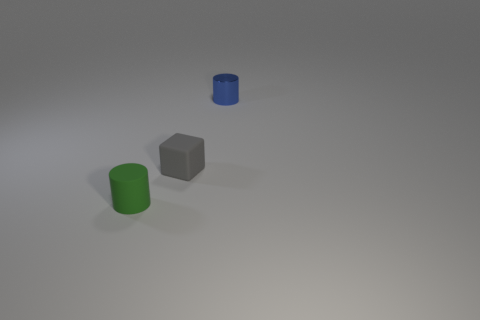What color is the small metallic cylinder?
Give a very brief answer. Blue. There is a cylinder that is left of the small blue object; does it have the same color as the shiny object?
Provide a succinct answer. No. What number of objects are either matte things that are behind the green matte object or large gray metallic blocks?
Offer a terse response. 1. What number of gray things are either tiny matte cylinders or small rubber objects?
Offer a terse response. 1. How many other objects are there of the same color as the matte block?
Keep it short and to the point. 0. Are there fewer matte cubes that are on the right side of the metallic thing than large gray things?
Your answer should be very brief. No. There is a cylinder that is to the right of the cylinder that is in front of the cylinder to the right of the gray rubber block; what color is it?
Your answer should be very brief. Blue. Is there any other thing that is made of the same material as the blue thing?
Provide a short and direct response. No. Is the number of small green cylinders that are in front of the small green cylinder less than the number of gray blocks that are in front of the metal thing?
Ensure brevity in your answer.  Yes. There is a small object that is to the right of the tiny matte cylinder and to the left of the metal cylinder; what is its shape?
Provide a succinct answer. Cube. 